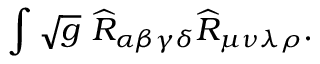<formula> <loc_0><loc_0><loc_500><loc_500>\int \sqrt { g } \widehat { R } _ { \alpha \beta \gamma \delta } \widehat { R } _ { \mu \nu \lambda \rho } .</formula> 